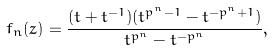<formula> <loc_0><loc_0><loc_500><loc_500>f _ { n } ( z ) = \frac { ( t + t ^ { - 1 } ) ( t ^ { p ^ { n } - 1 } - t ^ { - p ^ { n } + 1 } ) } { t ^ { p ^ { n } } - t ^ { - p ^ { n } } } ,</formula> 